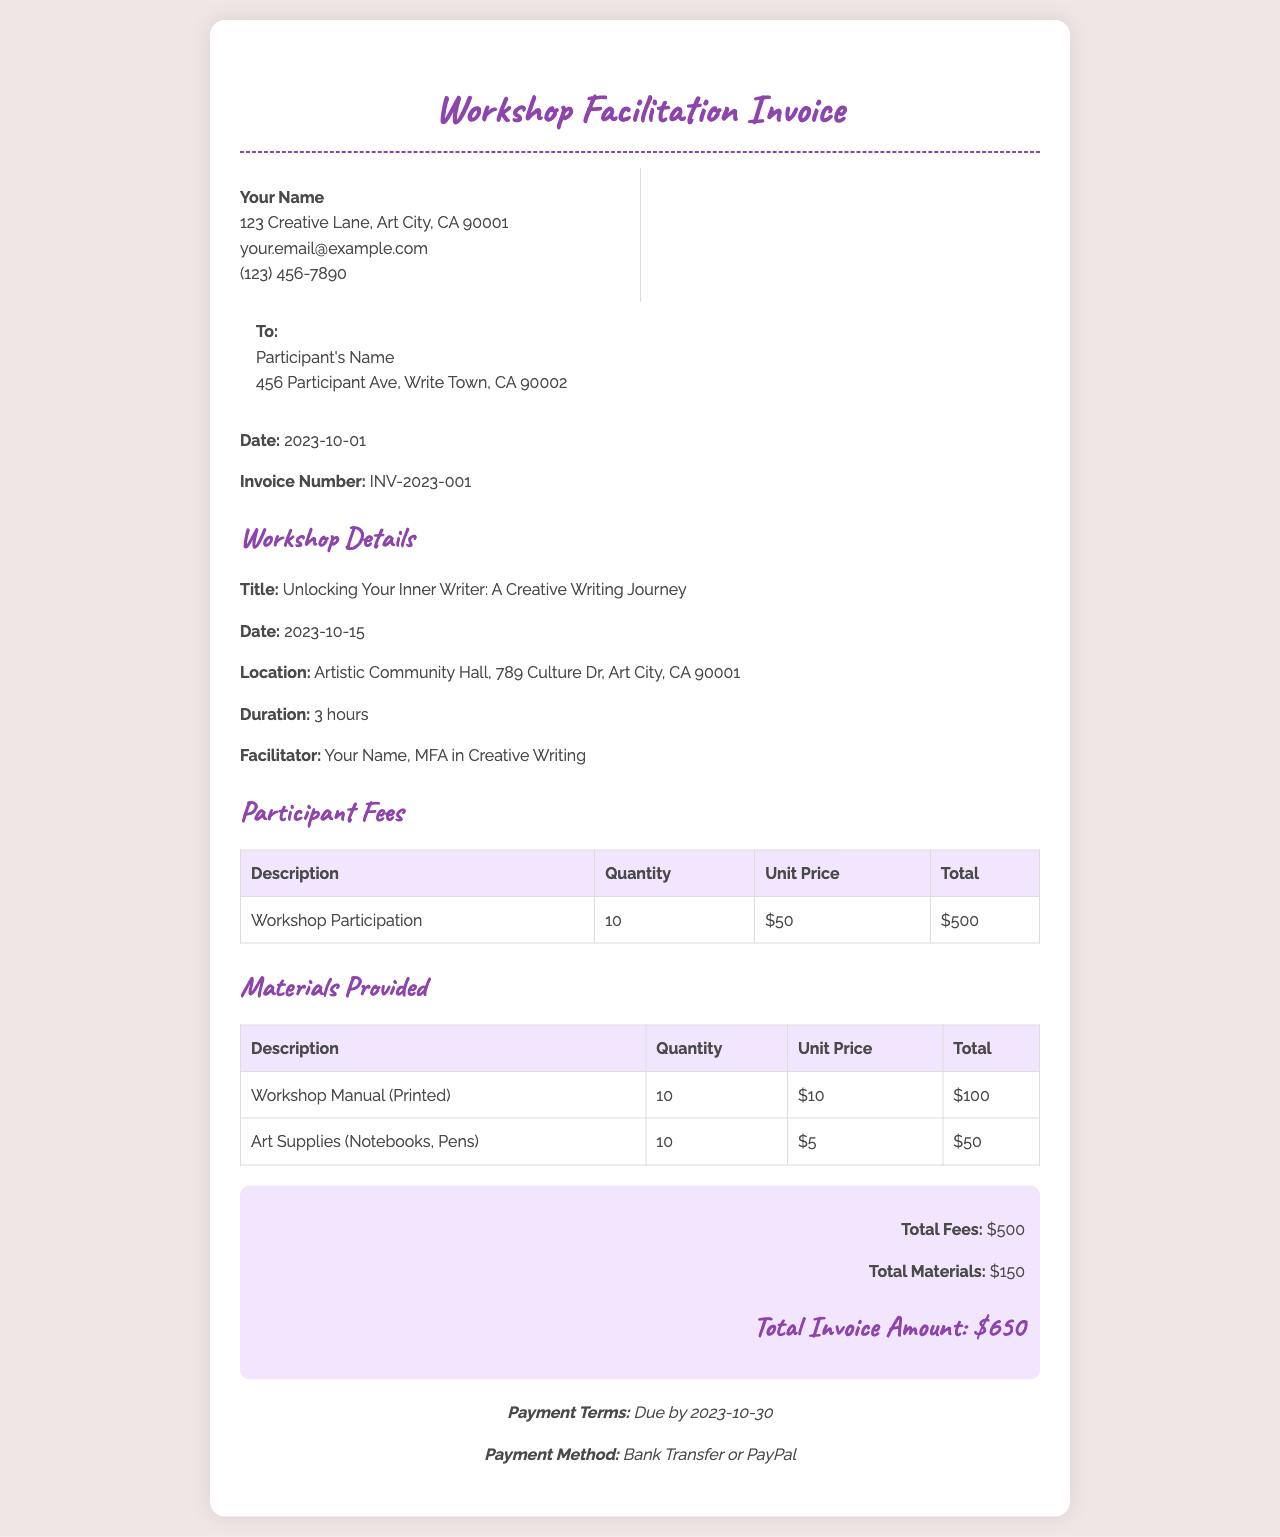what is the title of the workshop? The title of the workshop is stated clearly in the document and is "Unlocking Your Inner Writer: A Creative Writing Journey."
Answer: Unlocking Your Inner Writer: A Creative Writing Journey who is the facilitator of the workshop? The document mentions the facilitator's name and qualifications, which are "Your Name, MFA in Creative Writing."
Answer: Your Name, MFA in Creative Writing what is the total invoice amount? The total invoice amount is specified at the end of the fee summary section, which is $650.
Answer: $650 how many participants are in the workshop? The document provides the number of participants in the workshop, listed as 10 participants.
Answer: 10 when is the payment due? The payment terms section specifies that payment is due by 2023-10-30.
Answer: 2023-10-30 what materials were provided for the workshop? The document lists the materials provided; they include "Workshop Manual (Printed)" and "Art Supplies (Notebooks, Pens)."
Answer: Workshop Manual (Printed), Art Supplies (Notebooks, Pens) how much is charged for each workshop participant? The unit price for the workshop participation is provided, which is $50 per participant.
Answer: $50 what is the quantity of the workshop manuals provided? The document specifies that 10 printed workshop manuals were provided to participants.
Answer: 10 